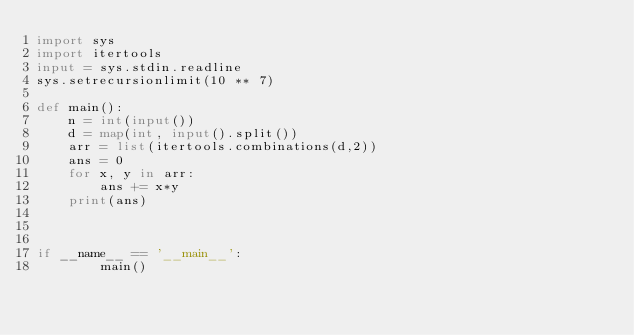Convert code to text. <code><loc_0><loc_0><loc_500><loc_500><_Python_>import sys
import itertools
input = sys.stdin.readline
sys.setrecursionlimit(10 ** 7)

def main():
    n = int(input())
    d = map(int, input().split())
    arr = list(itertools.combinations(d,2))
    ans = 0
    for x, y in arr:
        ans += x*y
    print(ans)



if __name__ == '__main__':
        main()
</code> 